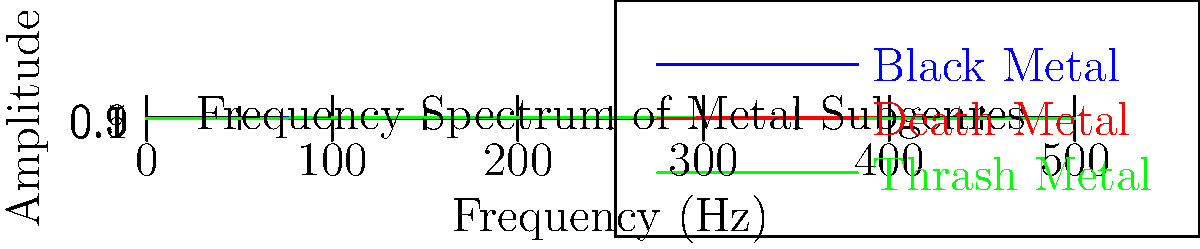Analyzing the frequency spectrum waveforms of different metal subgenres, which subgenre exhibits the highest amplitude in the mid-frequency range (around 200-300 Hz), and how might this relate to the characteristic sound of that subgenre? To answer this question, we need to analyze the waveforms presented in the graph:

1. Identify the mid-frequency range: The graph shows frequencies from 0 to 500 Hz, so the mid-frequency range (200-300 Hz) is in the middle of the x-axis.

2. Compare amplitudes in the mid-frequency range:
   - Black Metal (blue line): Shows high amplitude, peaking around 200-300 Hz.
   - Death Metal (red line): Also shows high amplitude, but slightly lower than Black Metal.
   - Thrash Metal (green line): Shows lower amplitude compared to the other two.

3. Determine the highest amplitude: Black Metal has the highest peak in the 200-300 Hz range.

4. Relate to characteristic sound:
   - Black Metal is known for its "raw" and "cold" sound.
   - The high amplitude in the mid-frequency range contributes to the prominent, harsh guitar tones.
   - This frequency range emphasizes the distorted guitar sounds, creating the signature "wall of sound" effect in Black Metal.

5. Consider the social context:
   - As a social worker attending metal concerts, understanding these sonic characteristics can help in recognizing how the music's intensity might influence crowd behavior and individual experiences.
Answer: Black Metal; high mid-frequency amplitudes create its raw, intense "wall of sound" effect. 